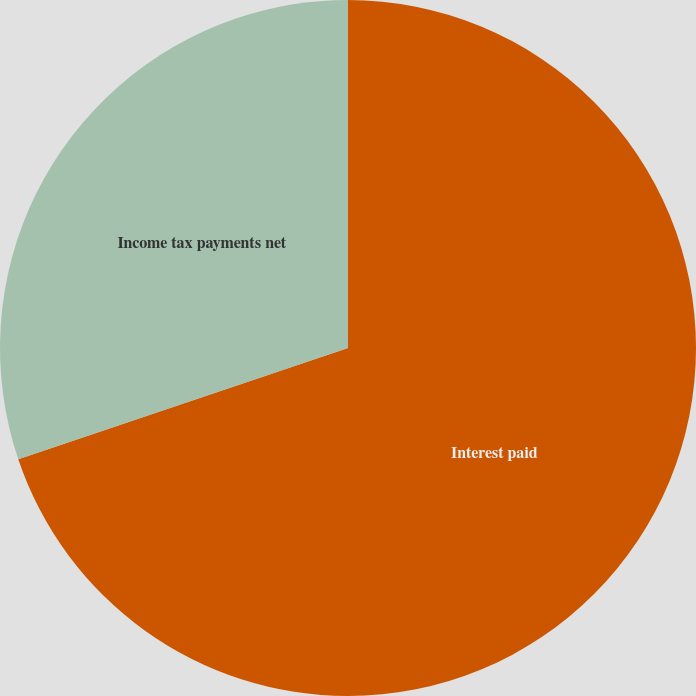Convert chart. <chart><loc_0><loc_0><loc_500><loc_500><pie_chart><fcel>Interest paid<fcel>Income tax payments net<nl><fcel>69.82%<fcel>30.18%<nl></chart> 